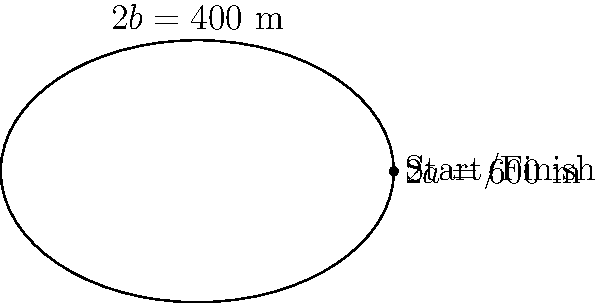A local cycling race is held on an oval track with a major axis of 600 meters and a minor axis of 400 meters. If a cyclist completes 50 laps, what is the total distance covered in kilometers? (Use $\pi \approx 3.14$) To solve this problem, we'll follow these steps:

1) The track is an ellipse. We need to find its circumference.

2) The formula for the circumference of an ellipse is approximately:
   $$C \approx 2\pi\sqrt{\frac{a^2 + b^2}{2}}$$
   where $a$ is half the major axis and $b$ is half the minor axis.

3) From the given information:
   $a = 600/2 = 300$ meters
   $b = 400/2 = 200$ meters

4) Substituting into the formula:
   $$C \approx 2\pi\sqrt{\frac{300^2 + 200^2}{2}}$$

5) Simplifying:
   $$C \approx 2\pi\sqrt{\frac{90000 + 40000}{2}} = 2\pi\sqrt{65000}$$

6) Calculating:
   $$C \approx 2 * 3.14 * \sqrt{65000} \approx 1608.45$$ meters

7) For 50 laps, the total distance is:
   $$50 * 1608.45 = 80422.5$$ meters

8) Converting to kilometers:
   $$80422.5 / 1000 = 80.4225$$ kilometers

Therefore, the cyclist covers approximately 80.42 km in 50 laps.
Answer: 80.42 km 